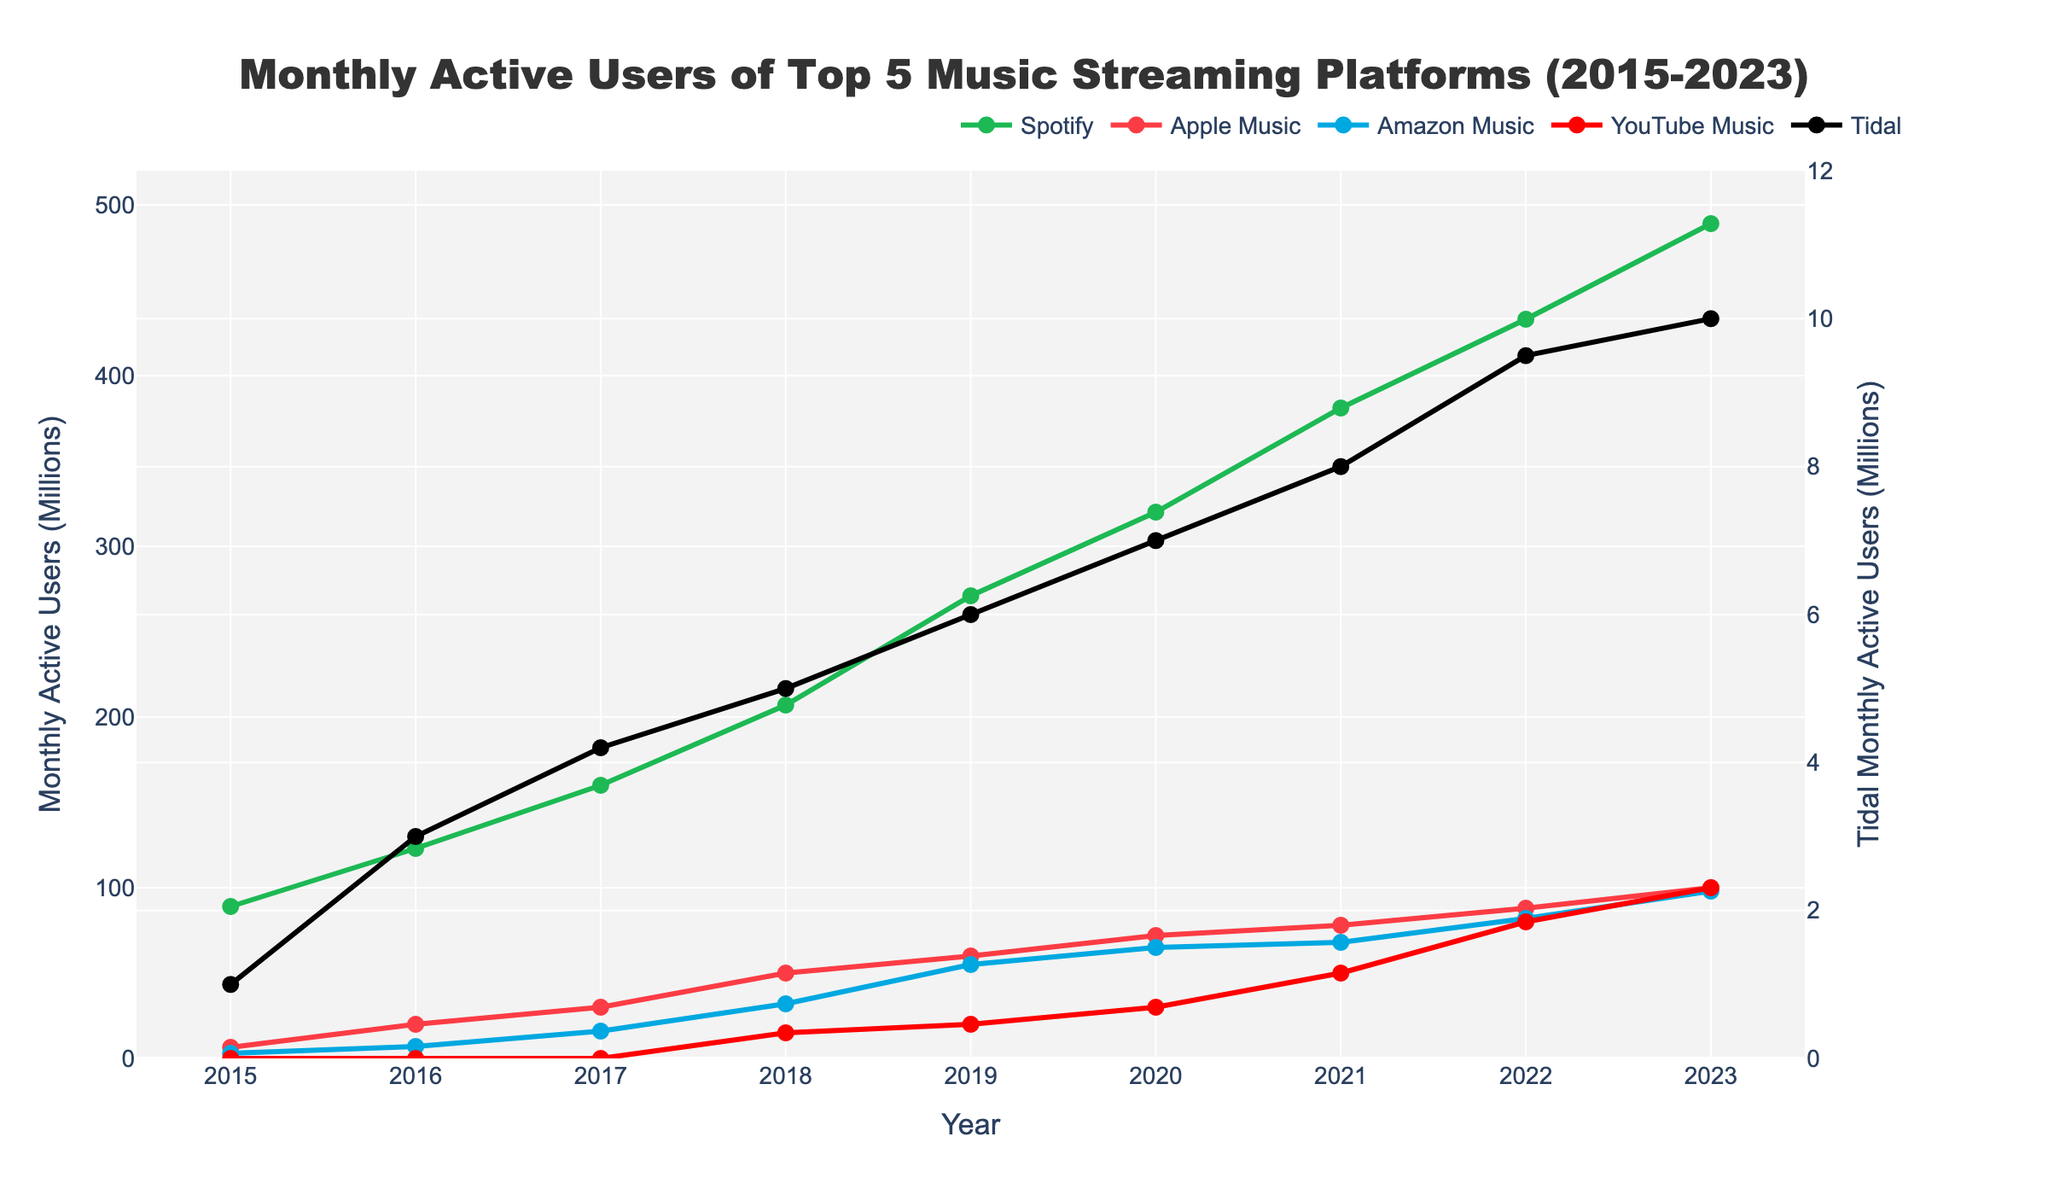Which platform had the highest growth in monthly active users from 2015 to 2023? To identify the platform with the highest growth, calculate the difference between the 2023 and 2015 values for each platform. Spotify increased by 400 million (489-89), Apple Music by 93.5 million (100-6.5), Amazon Music by 95 million (98-3), YouTube Music by 100 million (100-0), and Tidal by 9 million (10-1). YouTube Music had the highest growth of 100 million.
Answer: YouTube Music How many years did it take for Spotify to double its number of monthly active users from 2015? In 2015, Spotify had 89 million users. Doubling this number gives us 178 million users. We look at when Spotify's users exceed 178 million: this happens in 2018 with 207 million users. Therefore, it took 3 years (2018-2015) for Spotify to double its users.
Answer: 3 years Which platforms had more monthly active users than Tidal in 2017? Compare the monthly active users in 2017. Spotify had 160 million, Apple Music had 30 million, Amazon Music had 16 million, YouTube Music had 0, and Tidal had 4.2 million. So, Spotify, Apple Music, and Amazon Music had more users than Tidal.
Answer: Spotify, Apple Music, Amazon Music By how much did the number of YouTube Music users increase between 2020 and 2023? In 2020, YouTube Music had 30 million users, and in 2023, it had 100 million. The increase is 100 - 30 = 70 million users.
Answer: 70 million Which year saw the greatest increase for Apple Music in terms of monthly active users? Calculate the year-on-year difference for Apple Music. The differences are: 2016-2015: 20-6.5 = 13.5, 2017-2016: 30-20 = 10, 2018-2017: 50-30 = 20, 2019-2018: 60-50 = 10, 2020-2019: 72-60 = 12, 2021-2020: 78-72 = 6, 2022-2021: 88-78 = 10, 2023-2022: 100-88 = 12. Hence, the greatest increase was in 2018 with an increase of 20 million users.
Answer: 2018 